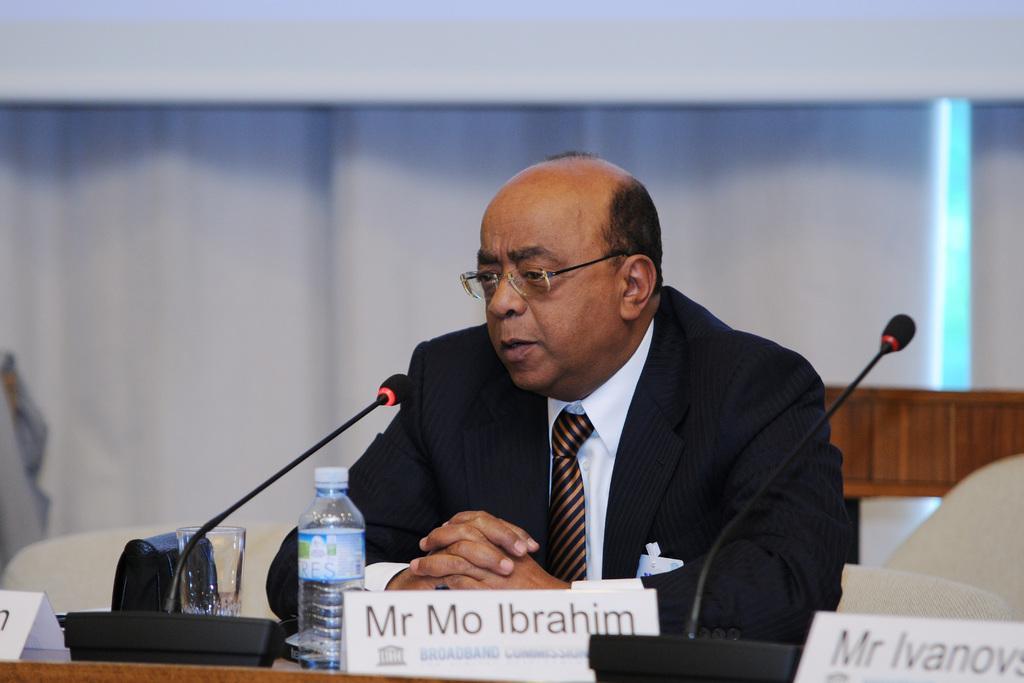Describe this image in one or two sentences. A man sitting on a chair at a table is speaking. 